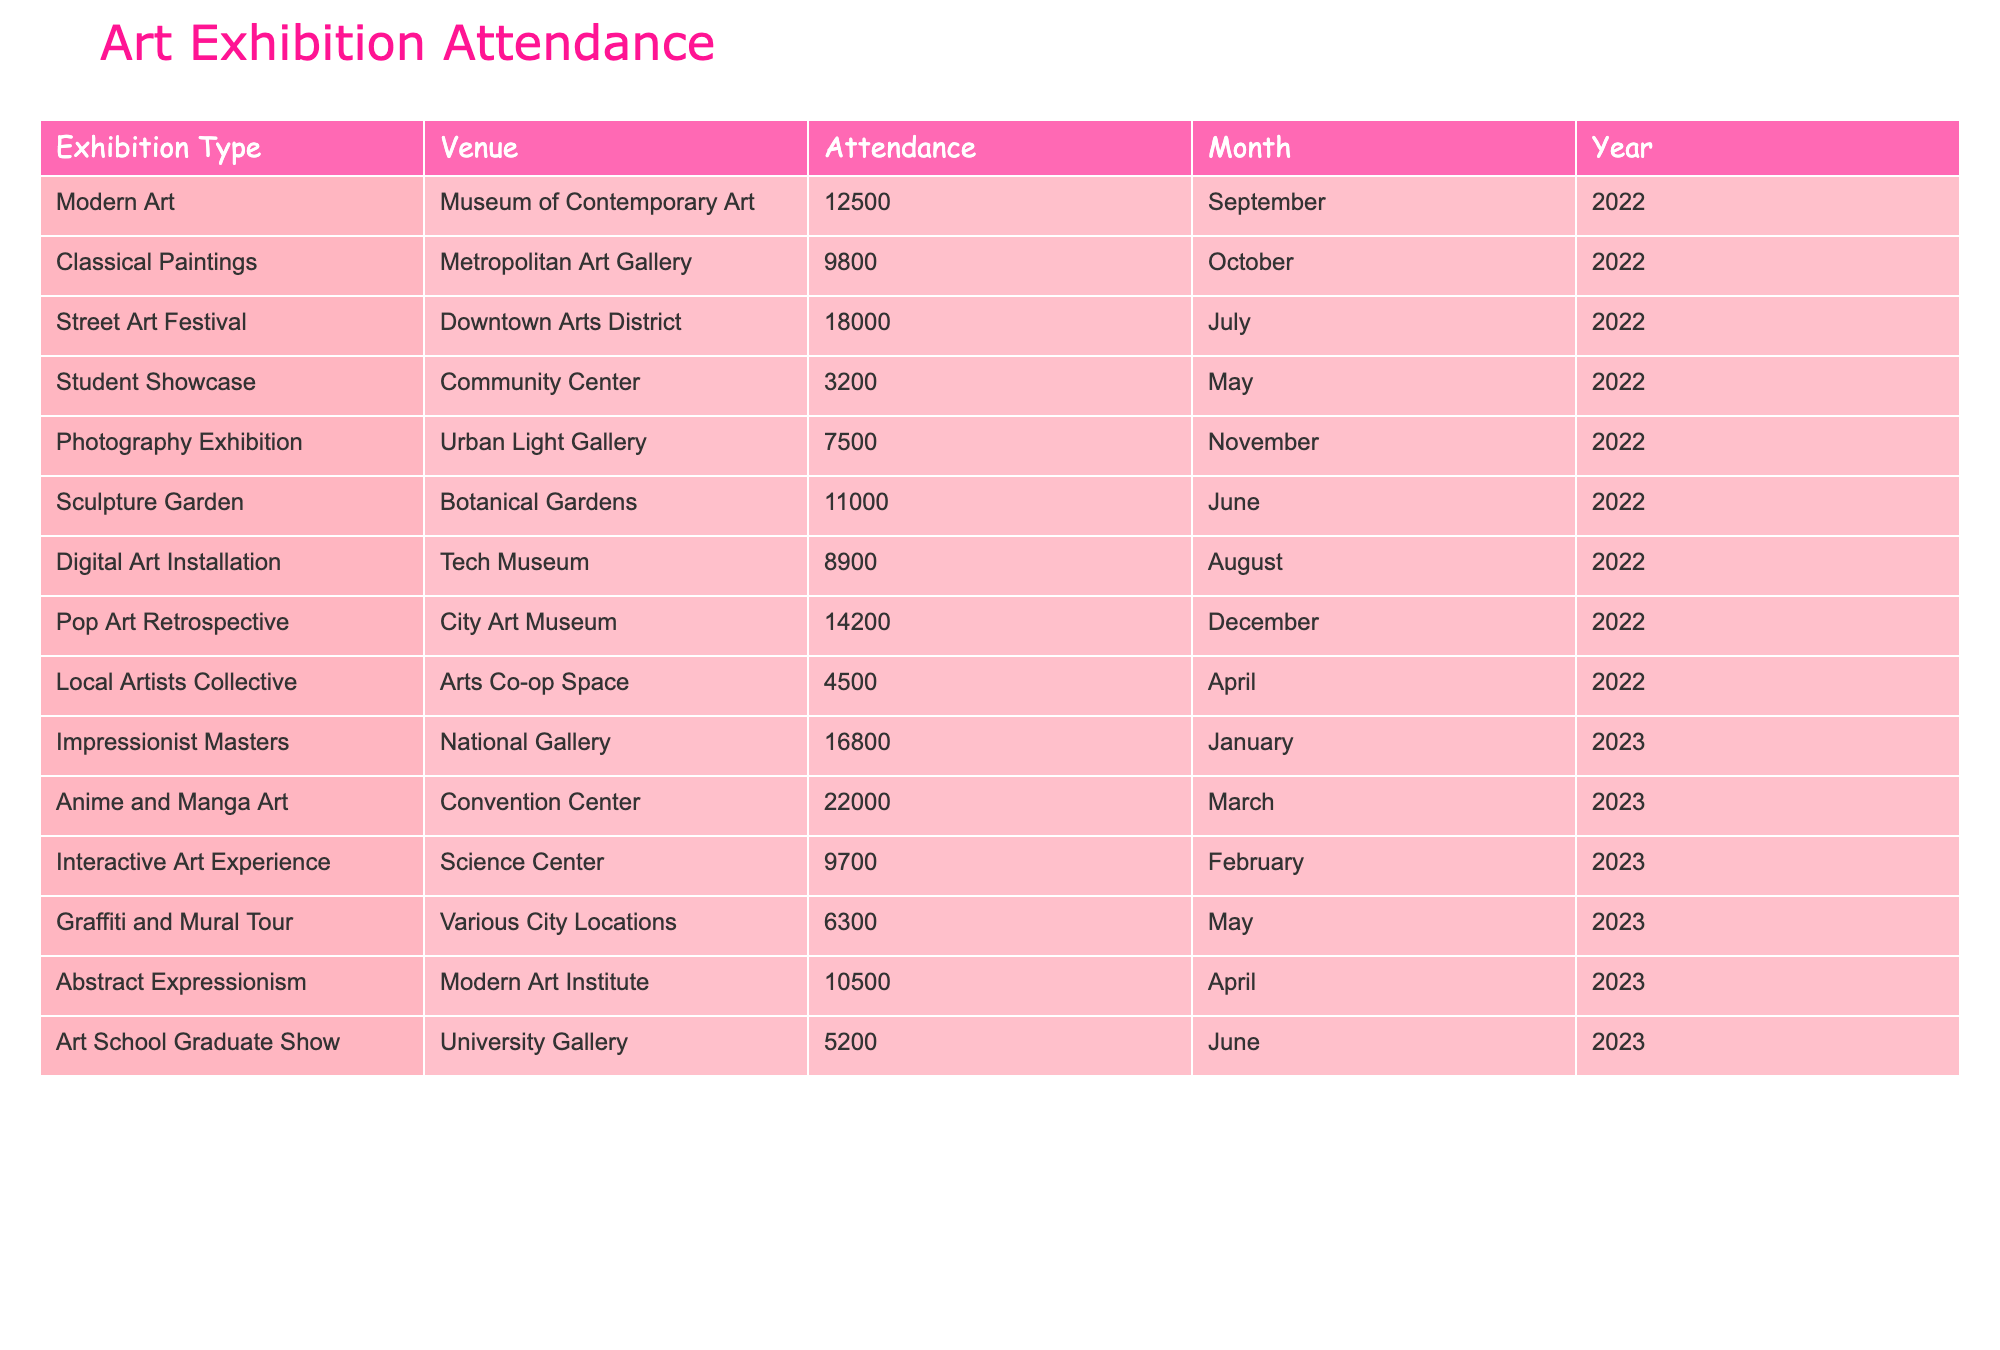What was the highest attended exhibition type in 2022? The highest attended exhibition in 2022 is the Anime and Manga Art, which had an attendance of 22,000 and occurred in March 2023. However, for the year 2022, the highest attendance was for the Street Art Festival with 18,000 attendees in July 2022.
Answer: 18,000 How many total people attended exhibitions in the month of December 2022? Only one exhibition occurred in December 2022, which was the Pop Art Retrospective, and it had an attendance of 14,200. Therefore, the total attendance for December 2022 is simply that number.
Answer: 14,200 What is the difference in attendance between the Street Art Festival and the Classical Paintings exhibition? The Street Art Festival had an attendance of 18,000 and the Classical Paintings exhibition had 9,800. The difference is calculated as 18,000 - 9,800 = 8,200.
Answer: 8,200 What was the average attendance at exhibitions held in May 2022? There were two exhibitions in May 2022: the Student Showcase with 3,200 attendees and the Graffiti and Mural Tour in May 2023 with 6,300. Adding the attendances gives 3,200 + 6,300 = 9,500. To find the average we take 9,500/2 = 4,750.
Answer: 4,750 In which month did the Sculpture Garden at the Botanical Gardens have its exhibition, and what was the attendance? The Sculpture Garden exhibition occurred in June 2022 and had an attendance of 11,000. Both pieces of information are directly available in the table.
Answer: June 2022, 11,000 Was the attendance of the Photography Exhibition higher than that of the Digital Art Installation? The Photography Exhibition had an attendance of 7,500 while the Digital Art Installation had 8,900. Since 7,500 is less than 8,900, the attendance of the Photography Exhibition was not higher.
Answer: No What are the total attendees for all art exhibitions in 2022? To find the total attendees in 2022, we add the attendance figures: 12,500 (Modern Art) + 9,800 (Classical Paintings) + 18,000 (Street Art Festival) + 3,200 (Student Showcase) + 7,500 (Photography Exhibition) + 11,000 (Sculpture Garden) + 8,900 (Digital Art Installation) + 4,500 (Local Artists Collective) = 75,400.
Answer: 75,400 Which exhibition type had the lowest attendance, and what was that figure? The exhibition type with the lowest attendance was the Student Showcase at the Community Center with 3,200 attendees. The table clearly displays these values, making it easy to identify the lowest.
Answer: 3,200 How many more people attended the Anime and Manga Art exhibition than the Impressionist Masters exhibition? The Anime and Manga Art exhibition had an attendance of 22,000, while the Impressionist Masters had 16,800. The difference is calculated as 22,000 - 16,800 = 5,200, showing that Anime and Manga Art received 5,200 more attendees.
Answer: 5,200 Which venue had the highest single exhibition attendance overall? The highest single exhibition attendance recorded in the table was for the Anime and Manga Art at the Convention Center with 22,000 attendees. The table allows for a quick comparison, which shows that this exhibition has the top attendance.
Answer: 22,000 